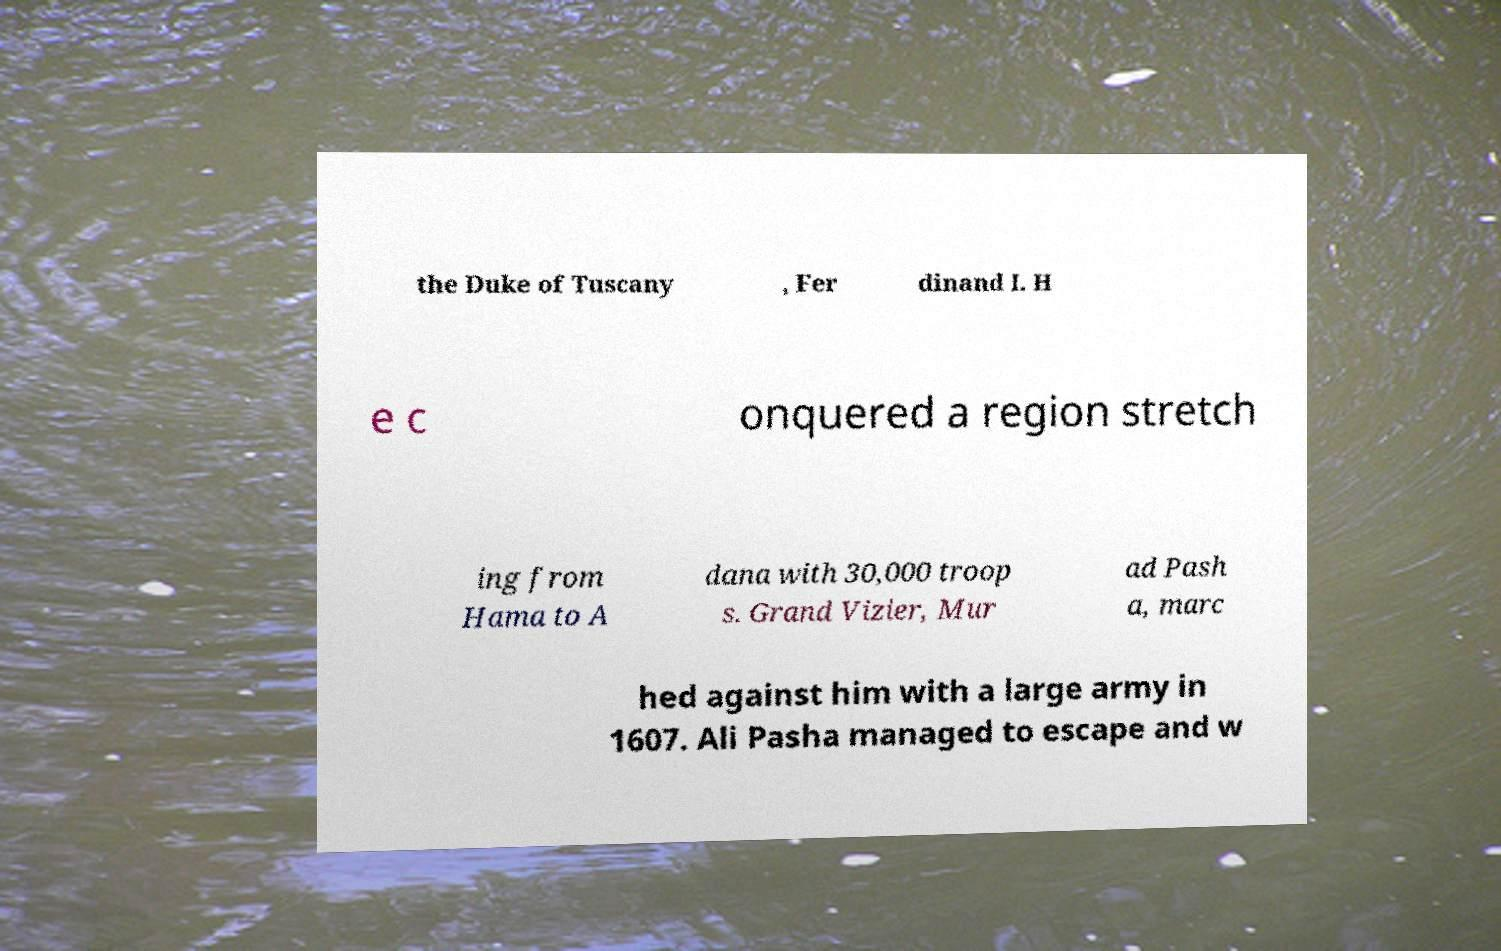Please read and relay the text visible in this image. What does it say? the Duke of Tuscany , Fer dinand I. H e c onquered a region stretch ing from Hama to A dana with 30,000 troop s. Grand Vizier, Mur ad Pash a, marc hed against him with a large army in 1607. Ali Pasha managed to escape and w 